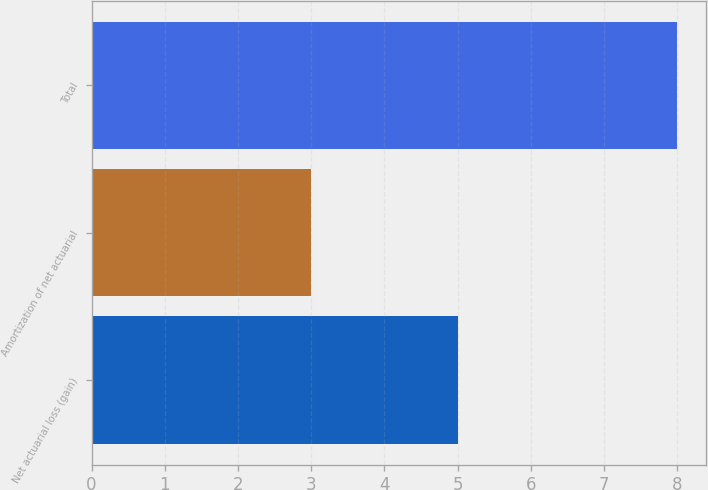Convert chart. <chart><loc_0><loc_0><loc_500><loc_500><bar_chart><fcel>Net actuarial loss (gain)<fcel>Amortization of net actuarial<fcel>Total<nl><fcel>5<fcel>3<fcel>8<nl></chart> 